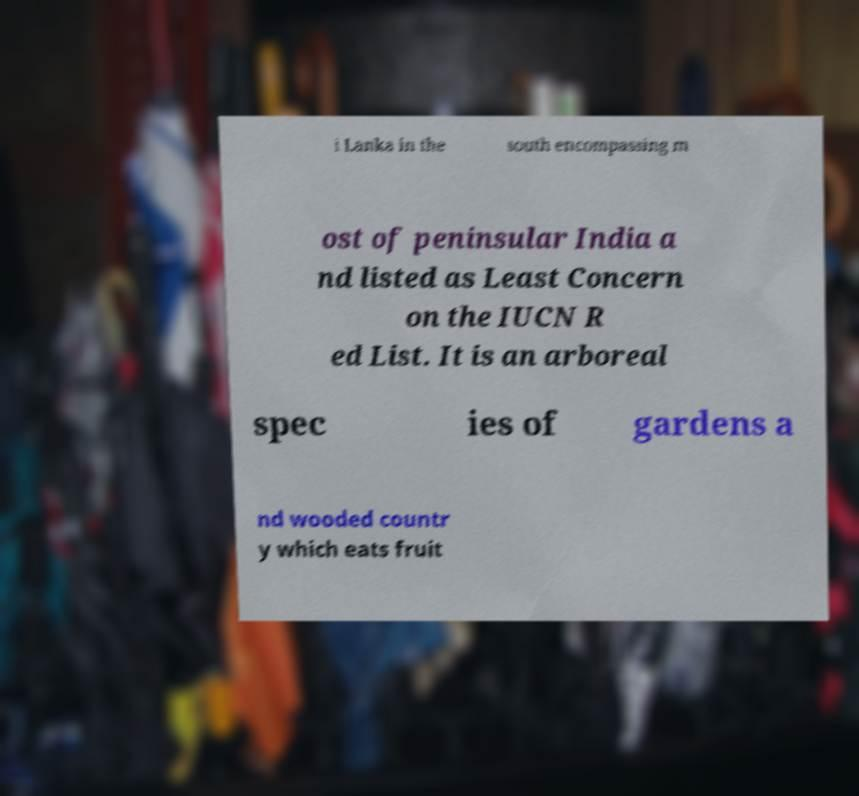I need the written content from this picture converted into text. Can you do that? i Lanka in the south encompassing m ost of peninsular India a nd listed as Least Concern on the IUCN R ed List. It is an arboreal spec ies of gardens a nd wooded countr y which eats fruit 